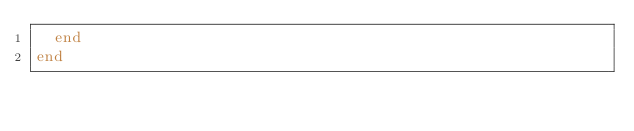Convert code to text. <code><loc_0><loc_0><loc_500><loc_500><_Ruby_>  end
end
</code> 